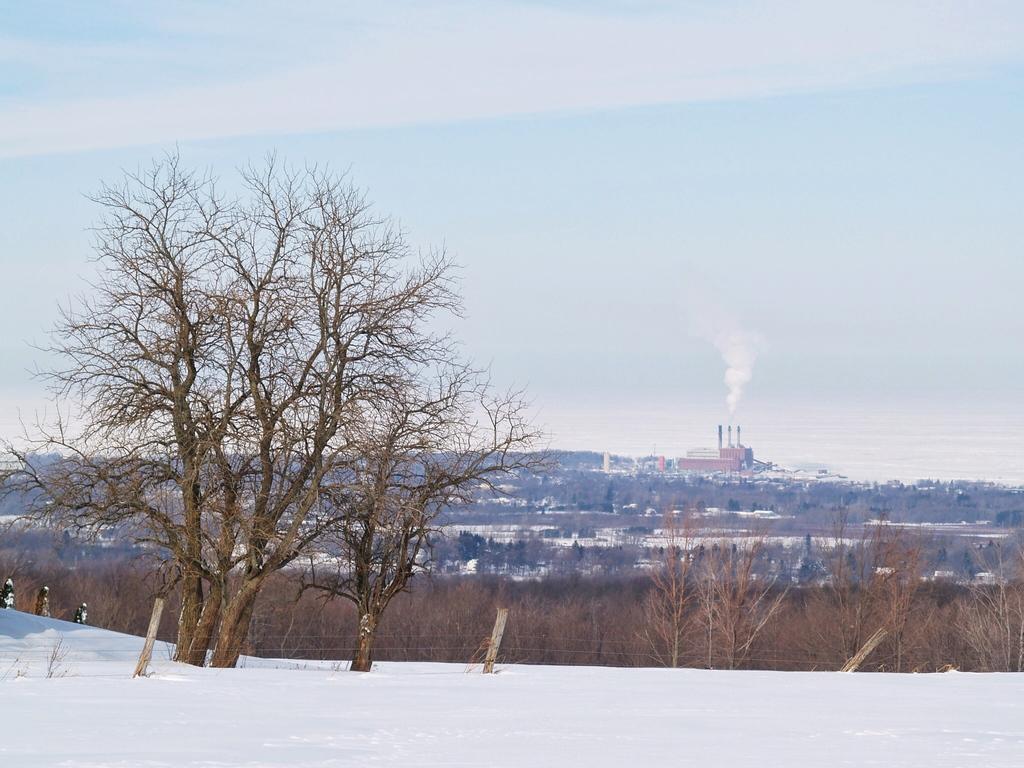Please provide a concise description of this image. In this image in the center there is snow on the ground and there are dry trees. In the background there are buildings and there are trees and there is a smoke coming out of the building which is in the center and the sky is cloudy. 